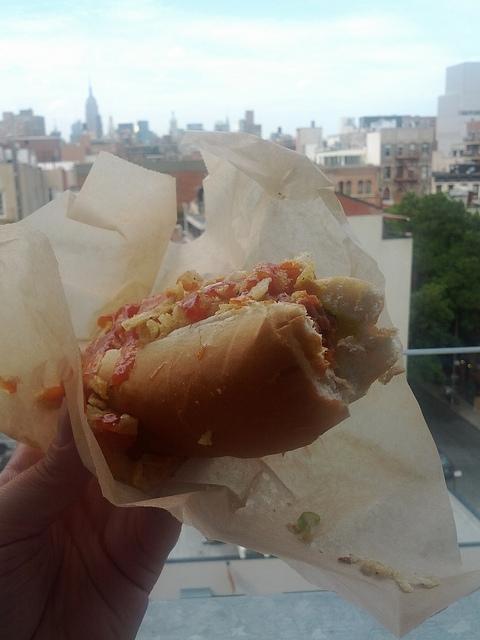Is there a banana in the bun?
Concise answer only. No. Is this hot dog plain?
Short answer required. No. What is wrapped up in a white paper?
Short answer required. Hot dog. How many thumbs are in this picture?
Short answer required. 1. 